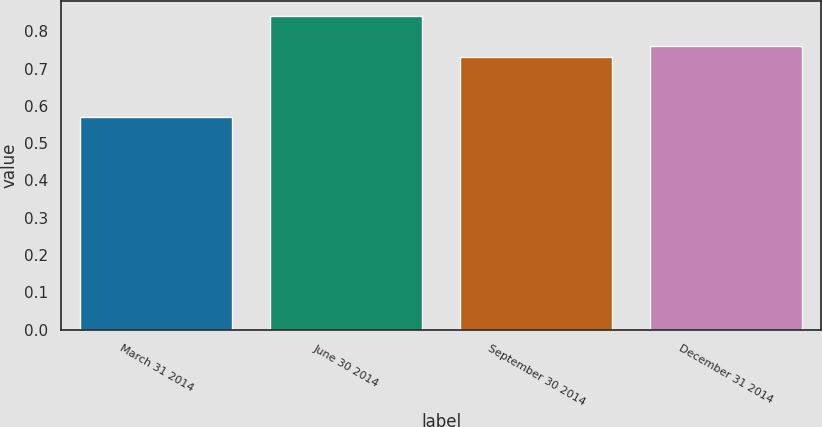Convert chart. <chart><loc_0><loc_0><loc_500><loc_500><bar_chart><fcel>March 31 2014<fcel>June 30 2014<fcel>September 30 2014<fcel>December 31 2014<nl><fcel>0.57<fcel>0.84<fcel>0.73<fcel>0.76<nl></chart> 